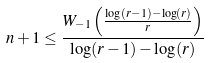Convert formula to latex. <formula><loc_0><loc_0><loc_500><loc_500>n + 1 \leq \frac { W _ { - 1 } \left ( \frac { \log ( r - 1 ) - \log ( r ) } { r } \right ) } { \log ( r - 1 ) - \log ( r ) }</formula> 